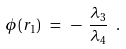Convert formula to latex. <formula><loc_0><loc_0><loc_500><loc_500>\phi ( r _ { 1 } ) \ = \ - \ \frac { \lambda _ { 3 } } { \lambda _ { 4 } } \ .</formula> 